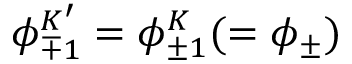Convert formula to latex. <formula><loc_0><loc_0><loc_500><loc_500>\phi _ { \mp 1 } ^ { K ^ { \prime } } = \phi _ { \pm 1 } ^ { K } ( = \phi _ { \pm } )</formula> 